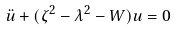Convert formula to latex. <formula><loc_0><loc_0><loc_500><loc_500>\ddot { u } + ( \zeta ^ { 2 } - \lambda ^ { 2 } - W ) u = 0</formula> 